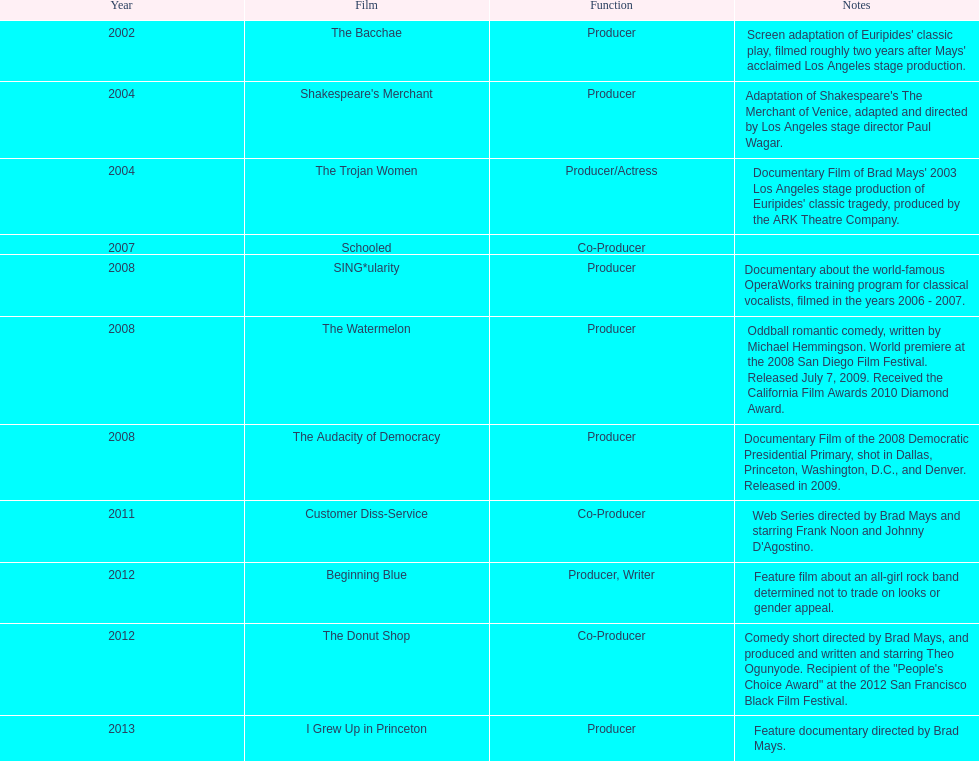How many years before was the film bacchae out before the watermelon? 6. 